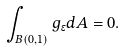Convert formula to latex. <formula><loc_0><loc_0><loc_500><loc_500>\int _ { B ( 0 , 1 ) } g _ { \epsilon } d A = 0 .</formula> 